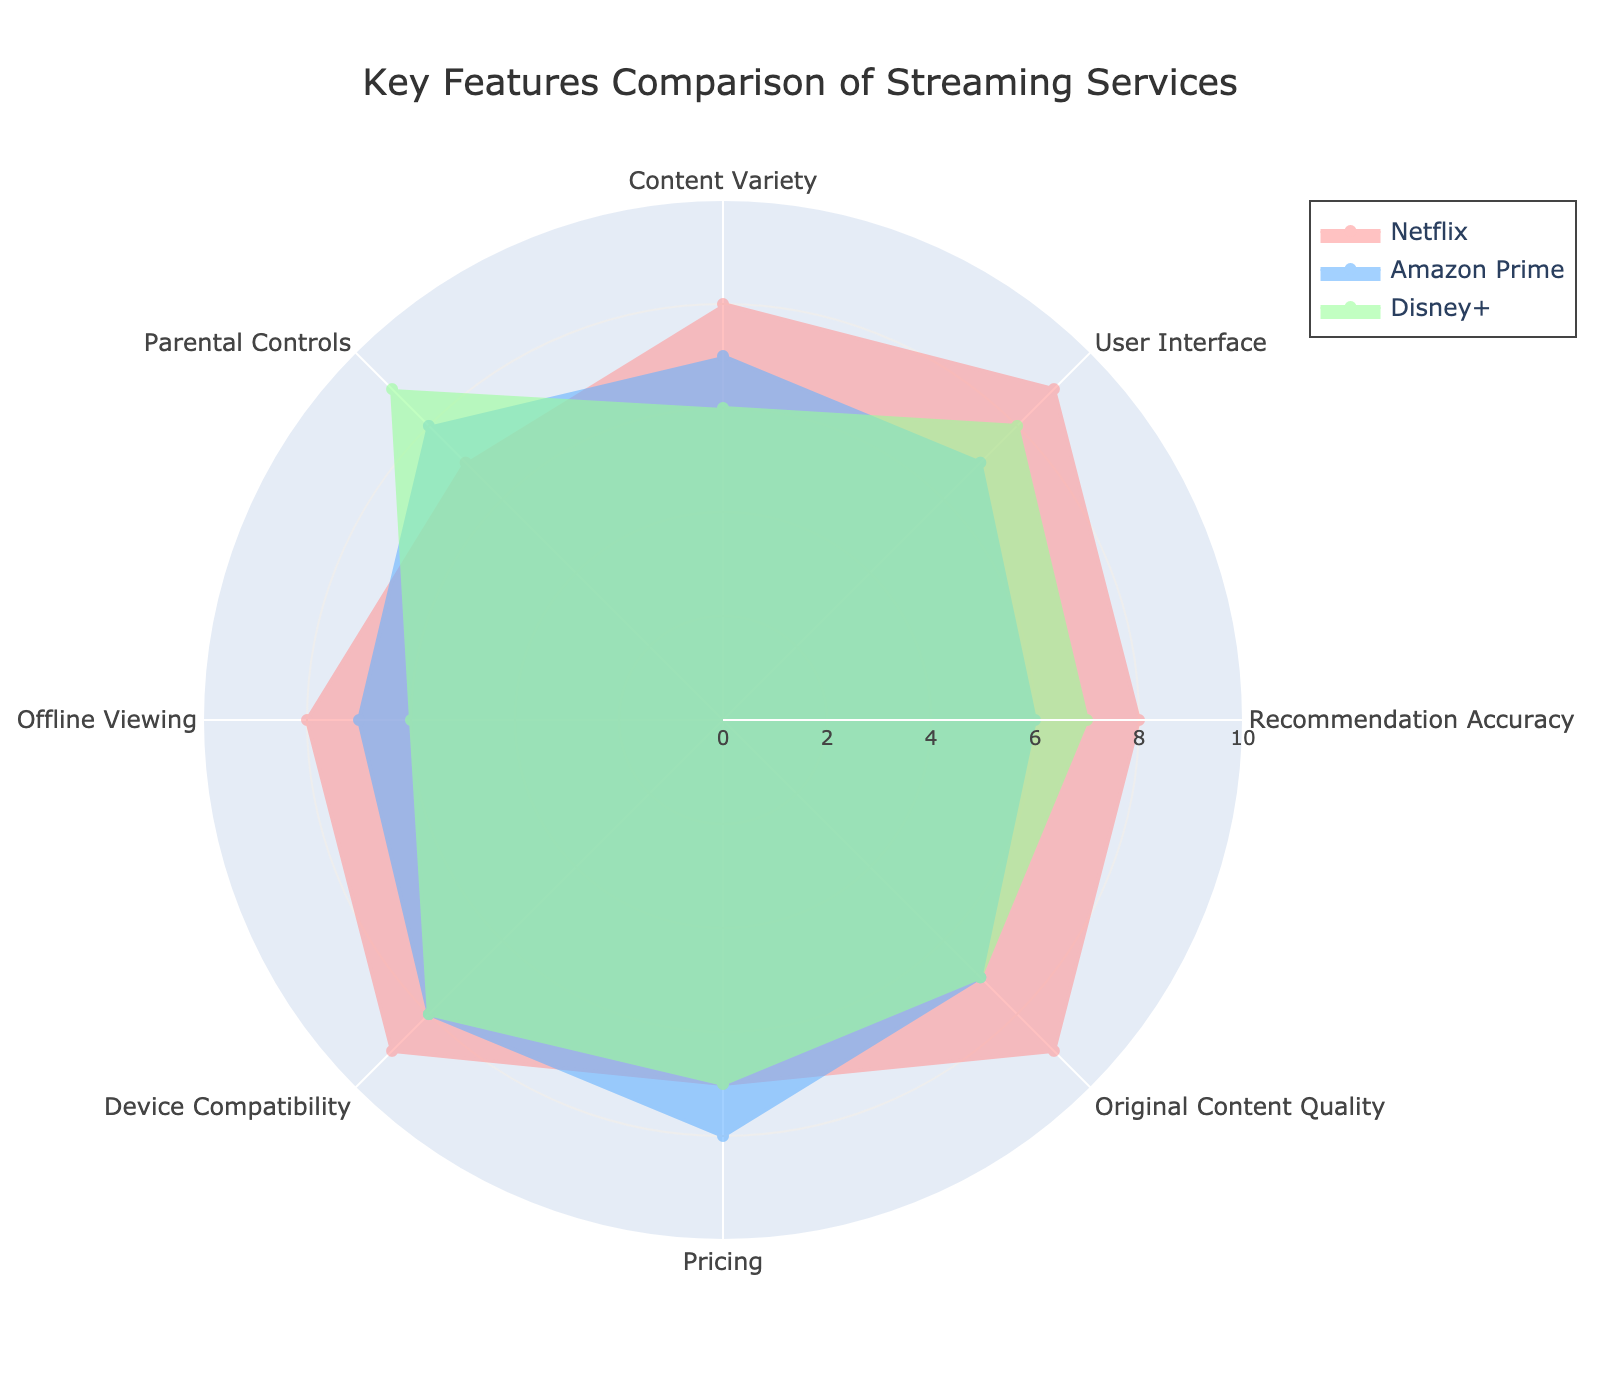What is the title of the radar chart? The title of the radar chart is positioned at the top center. The chart title is typically rendered in a larger and bold font.
Answer: Key Features Comparison of Streaming Services How many streaming services are compared in the radar chart? The legend of the radar chart indicates the number of streaming services compared. Each service is denoted by a different color.
Answer: 3 Which streaming service has the highest score in User Interface? Locate the "User Interface" feature on the radar chart and compare the ratings for each streaming service. Identify the service with the highest rating value.
Answer: Netflix What is the average score of Amazon Prime for all features? Sum the scores for Amazon Prime for all features and divide by the number of features.
Calculation: (7 + 7 + 6 + 7 + 8 + 8 + 7 + 8) = 58. Then, divide by 8 features.
Answer: 7.25 Which streaming service has the lowest score in Parental Controls? Locate the "Parental Controls" feature on the radar chart and compare the ratings for each streaming service. Identify the service with the lowest rating value.
Answer: HBO Max How does the Content Variety score of Disney+ compare to Netflix and Amazon Prime? Locate the "Content Variety" feature on the radar chart and compare the scores for Disney+, Netflix, and Amazon Prime.
Disney+: 6
Netflix: 8
Amazon Prime: 7
Answer: Disney+ has a lower score than both Netflix and Amazon Prime Which feature does Netflix score the highest and lowest in? For Netflix, examine each feature on the radar chart to determine the maximum and minimum scores.
Highest: Original Content Quality or User Interface (9)
Lowest: Parental Controls (7)
Answer: Highest: Original Content Quality or User Interface (9), Lowest: Parental Controls (7) What is the total score for Disney+ in all features combined? Sum the scores of Disney+ for all features.
Calculation: (6 + 8 + 7 + 7 + 7 + 8 + 6 + 9) = 58
Answer: 58 Which feature has the greatest variation in scores among the three services? Compare the score ranges for each feature across the three services. The feature with the highest difference between the maximum and minimum scores shows the greatest variation.
- Example Comparison: Recommendation Accuracy range (8 - 5 = 3), Parental Controls range (9 - 6 = 3), Offline Viewing range (8 - 5 = 3). 
(Note: For exact identification, review differences for each feature systematically.)
Answer: Parental Controls (range of 3) 